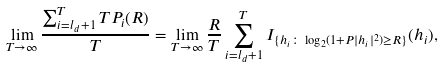Convert formula to latex. <formula><loc_0><loc_0><loc_500><loc_500>\lim _ { T \rightarrow \infty } \frac { \sum _ { i = l _ { d } + 1 } ^ { T } T P _ { i } ( R ) } { T } = \lim _ { T \rightarrow \infty } \frac { R } { T } \sum _ { i = l _ { d } + 1 } ^ { T } I _ { \{ h _ { i } \colon \log _ { 2 } ( 1 + P | h _ { i } | ^ { 2 } ) \geq R \} } ( h _ { i } ) ,</formula> 